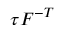<formula> <loc_0><loc_0><loc_500><loc_500>{ \tau } { F } ^ { - T }</formula> 